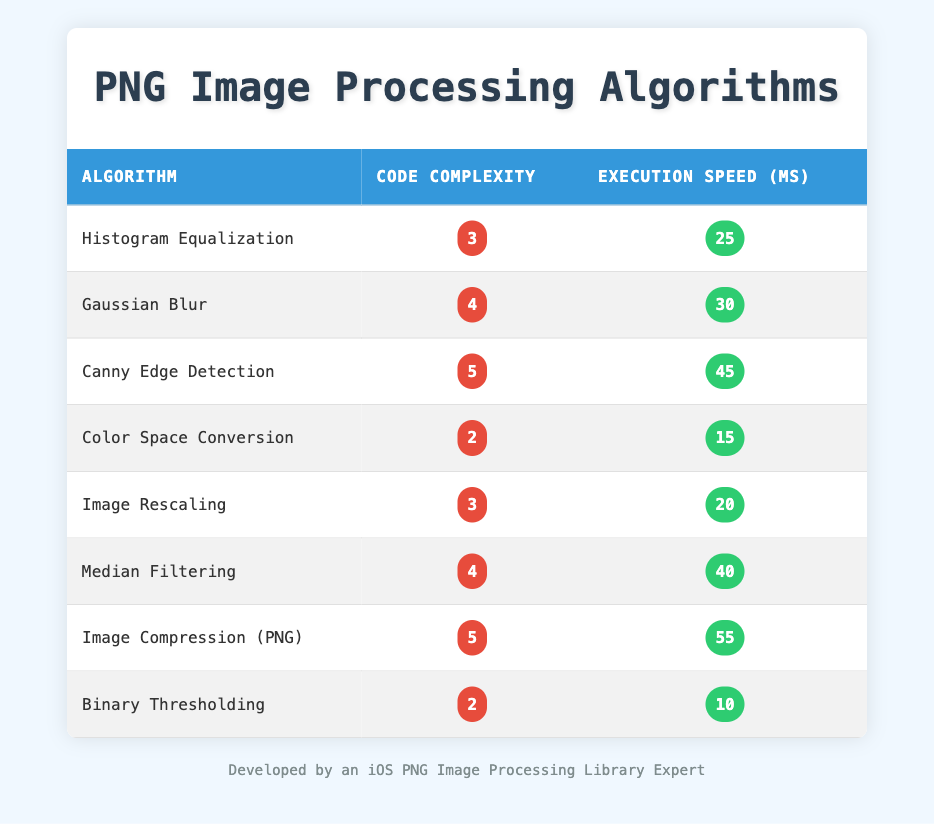What is the execution speed for Color Space Conversion? The table lists the execution speed for Color Space Conversion as 15 ms. This information is directly found in the row corresponding to the Color Space Conversion algorithm.
Answer: 15 ms Which algorithm has the highest code complexity? By looking through the codes in the table, Canny Edge Detection and Image Compression both have the highest code complexity value of 5. Thus, they are the algorithms with the maximum complexity.
Answer: Canny Edge Detection and Image Compression What is the average execution speed of the algorithms with a code complexity of 4? The algorithms with a code complexity of 4 are Gaussian Blur and Median Filtering. Their execution speeds are 30 ms and 40 ms, respectively. We calculate the average speed as (30 + 40) / 2 = 35 ms.
Answer: 35 ms Is there an algorithm with a code complexity of 2 that has an execution speed greater than 20 ms? Looking at the table, Binary Thresholding has a code complexity of 2 and an execution speed of 10 ms. The other algorithm with the same complexity, Color Space Conversion, has a speed of 15 ms. Therefore, both have speeds less than 20 ms.
Answer: No Which algorithm has the lowest execution speed, and what is that speed? The row for Binary Thresholding shows the lowest execution speed of 10 ms. Therefore, it can be concluded that this algorithm has the minimum execution time among the listed algorithms.
Answer: 10 ms If you increase the code complexity by 1 for Histogram Equalization, what would the new code complexity be and how does that affect its execution speed? Histogram Equalization has a current code complexity of 3. If increased by 1, the new complexity would be 4. The execution speed remains unaffected by this change, which is currently 25 ms for the original complexity.
Answer: New complexity: 4, Execution speed: 25 ms How many algorithms have an execution speed greater than or equal to 30 ms? Referring to the table, the algorithms with execution speeds of 30 ms or more are Gaussian Blur, Canny Edge Detection, Median Filtering, and Image Compression (PNG), totaling four algorithms.
Answer: 4 algorithms What is the difference in execution speed between the algorithms with the highest and lowest code complexity? The highest code complexity is 5 (for Canny Edge Detection and Image Compression) with speeds of 45 ms and 55 ms, respectively. The lowest code complexity is 2 (for Binary Thresholding and Color Space Conversion) with speeds of 10 ms and 15 ms. The difference between the highest and lowest speeds is 55 - 10 = 45 ms.
Answer: 45 ms 